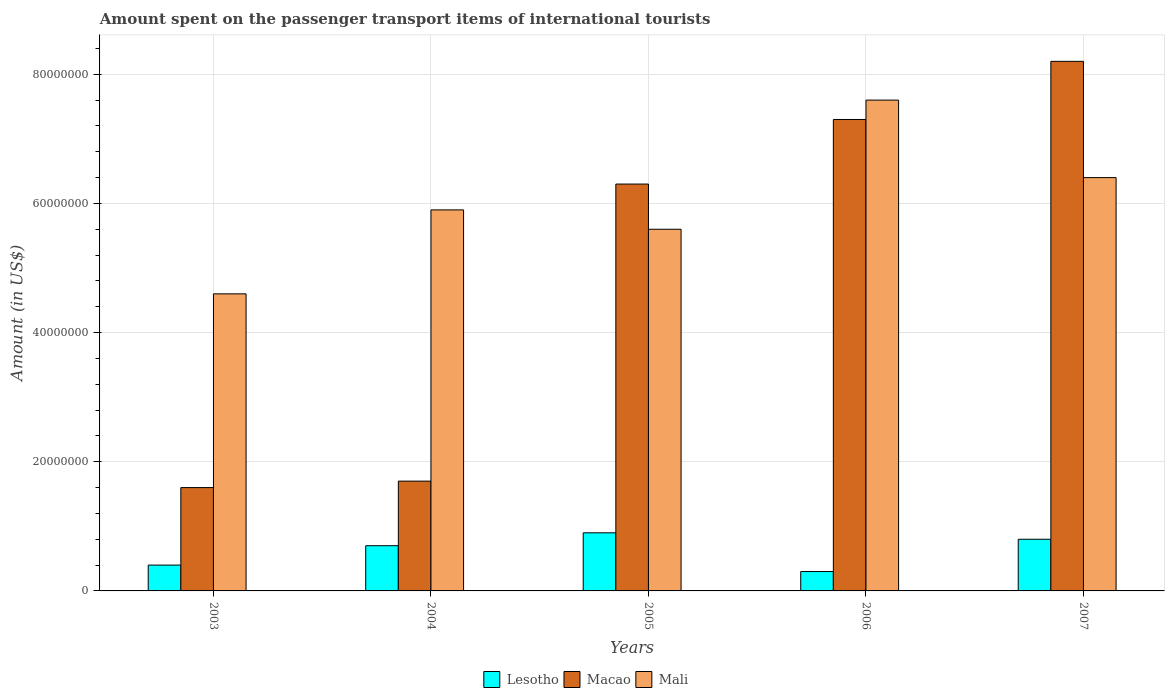Are the number of bars per tick equal to the number of legend labels?
Your answer should be compact. Yes. Are the number of bars on each tick of the X-axis equal?
Give a very brief answer. Yes. How many bars are there on the 4th tick from the left?
Make the answer very short. 3. What is the amount spent on the passenger transport items of international tourists in Mali in 2004?
Make the answer very short. 5.90e+07. Across all years, what is the maximum amount spent on the passenger transport items of international tourists in Mali?
Make the answer very short. 7.60e+07. Across all years, what is the minimum amount spent on the passenger transport items of international tourists in Macao?
Keep it short and to the point. 1.60e+07. In which year was the amount spent on the passenger transport items of international tourists in Mali maximum?
Offer a terse response. 2006. In which year was the amount spent on the passenger transport items of international tourists in Lesotho minimum?
Make the answer very short. 2006. What is the total amount spent on the passenger transport items of international tourists in Mali in the graph?
Provide a succinct answer. 3.01e+08. What is the difference between the amount spent on the passenger transport items of international tourists in Macao in 2005 and that in 2006?
Ensure brevity in your answer.  -1.00e+07. What is the difference between the amount spent on the passenger transport items of international tourists in Lesotho in 2007 and the amount spent on the passenger transport items of international tourists in Macao in 2003?
Your response must be concise. -8.00e+06. What is the average amount spent on the passenger transport items of international tourists in Lesotho per year?
Offer a terse response. 6.20e+06. In the year 2006, what is the difference between the amount spent on the passenger transport items of international tourists in Macao and amount spent on the passenger transport items of international tourists in Lesotho?
Provide a short and direct response. 7.00e+07. In how many years, is the amount spent on the passenger transport items of international tourists in Macao greater than 72000000 US$?
Offer a terse response. 2. What is the ratio of the amount spent on the passenger transport items of international tourists in Macao in 2003 to that in 2007?
Offer a terse response. 0.2. Is the difference between the amount spent on the passenger transport items of international tourists in Macao in 2005 and 2007 greater than the difference between the amount spent on the passenger transport items of international tourists in Lesotho in 2005 and 2007?
Ensure brevity in your answer.  No. What is the difference between the highest and the second highest amount spent on the passenger transport items of international tourists in Macao?
Keep it short and to the point. 9.00e+06. What is the difference between the highest and the lowest amount spent on the passenger transport items of international tourists in Macao?
Offer a very short reply. 6.60e+07. What does the 3rd bar from the left in 2003 represents?
Your answer should be very brief. Mali. What does the 2nd bar from the right in 2004 represents?
Offer a very short reply. Macao. Is it the case that in every year, the sum of the amount spent on the passenger transport items of international tourists in Lesotho and amount spent on the passenger transport items of international tourists in Mali is greater than the amount spent on the passenger transport items of international tourists in Macao?
Offer a very short reply. No. What is the difference between two consecutive major ticks on the Y-axis?
Your response must be concise. 2.00e+07. Are the values on the major ticks of Y-axis written in scientific E-notation?
Your answer should be compact. No. How many legend labels are there?
Offer a terse response. 3. What is the title of the graph?
Give a very brief answer. Amount spent on the passenger transport items of international tourists. What is the label or title of the X-axis?
Offer a terse response. Years. What is the label or title of the Y-axis?
Provide a short and direct response. Amount (in US$). What is the Amount (in US$) of Lesotho in 2003?
Your answer should be compact. 4.00e+06. What is the Amount (in US$) in Macao in 2003?
Offer a terse response. 1.60e+07. What is the Amount (in US$) of Mali in 2003?
Keep it short and to the point. 4.60e+07. What is the Amount (in US$) of Macao in 2004?
Offer a very short reply. 1.70e+07. What is the Amount (in US$) in Mali in 2004?
Offer a terse response. 5.90e+07. What is the Amount (in US$) in Lesotho in 2005?
Give a very brief answer. 9.00e+06. What is the Amount (in US$) of Macao in 2005?
Provide a short and direct response. 6.30e+07. What is the Amount (in US$) of Mali in 2005?
Your response must be concise. 5.60e+07. What is the Amount (in US$) of Macao in 2006?
Ensure brevity in your answer.  7.30e+07. What is the Amount (in US$) of Mali in 2006?
Your response must be concise. 7.60e+07. What is the Amount (in US$) in Macao in 2007?
Your answer should be compact. 8.20e+07. What is the Amount (in US$) in Mali in 2007?
Keep it short and to the point. 6.40e+07. Across all years, what is the maximum Amount (in US$) of Lesotho?
Provide a succinct answer. 9.00e+06. Across all years, what is the maximum Amount (in US$) of Macao?
Provide a short and direct response. 8.20e+07. Across all years, what is the maximum Amount (in US$) in Mali?
Offer a terse response. 7.60e+07. Across all years, what is the minimum Amount (in US$) in Macao?
Your response must be concise. 1.60e+07. Across all years, what is the minimum Amount (in US$) in Mali?
Your answer should be compact. 4.60e+07. What is the total Amount (in US$) of Lesotho in the graph?
Your response must be concise. 3.10e+07. What is the total Amount (in US$) of Macao in the graph?
Your response must be concise. 2.51e+08. What is the total Amount (in US$) in Mali in the graph?
Give a very brief answer. 3.01e+08. What is the difference between the Amount (in US$) in Lesotho in 2003 and that in 2004?
Offer a very short reply. -3.00e+06. What is the difference between the Amount (in US$) in Macao in 2003 and that in 2004?
Offer a terse response. -1.00e+06. What is the difference between the Amount (in US$) of Mali in 2003 and that in 2004?
Keep it short and to the point. -1.30e+07. What is the difference between the Amount (in US$) of Lesotho in 2003 and that in 2005?
Keep it short and to the point. -5.00e+06. What is the difference between the Amount (in US$) in Macao in 2003 and that in 2005?
Your answer should be very brief. -4.70e+07. What is the difference between the Amount (in US$) of Mali in 2003 and that in 2005?
Keep it short and to the point. -1.00e+07. What is the difference between the Amount (in US$) of Lesotho in 2003 and that in 2006?
Your answer should be very brief. 1.00e+06. What is the difference between the Amount (in US$) of Macao in 2003 and that in 2006?
Give a very brief answer. -5.70e+07. What is the difference between the Amount (in US$) in Mali in 2003 and that in 2006?
Ensure brevity in your answer.  -3.00e+07. What is the difference between the Amount (in US$) in Lesotho in 2003 and that in 2007?
Offer a terse response. -4.00e+06. What is the difference between the Amount (in US$) in Macao in 2003 and that in 2007?
Offer a terse response. -6.60e+07. What is the difference between the Amount (in US$) of Mali in 2003 and that in 2007?
Give a very brief answer. -1.80e+07. What is the difference between the Amount (in US$) in Macao in 2004 and that in 2005?
Give a very brief answer. -4.60e+07. What is the difference between the Amount (in US$) of Mali in 2004 and that in 2005?
Provide a short and direct response. 3.00e+06. What is the difference between the Amount (in US$) of Macao in 2004 and that in 2006?
Keep it short and to the point. -5.60e+07. What is the difference between the Amount (in US$) in Mali in 2004 and that in 2006?
Your response must be concise. -1.70e+07. What is the difference between the Amount (in US$) of Lesotho in 2004 and that in 2007?
Ensure brevity in your answer.  -1.00e+06. What is the difference between the Amount (in US$) in Macao in 2004 and that in 2007?
Your response must be concise. -6.50e+07. What is the difference between the Amount (in US$) in Mali in 2004 and that in 2007?
Ensure brevity in your answer.  -5.00e+06. What is the difference between the Amount (in US$) of Lesotho in 2005 and that in 2006?
Provide a short and direct response. 6.00e+06. What is the difference between the Amount (in US$) of Macao in 2005 and that in 2006?
Your answer should be very brief. -1.00e+07. What is the difference between the Amount (in US$) of Mali in 2005 and that in 2006?
Your response must be concise. -2.00e+07. What is the difference between the Amount (in US$) in Lesotho in 2005 and that in 2007?
Keep it short and to the point. 1.00e+06. What is the difference between the Amount (in US$) of Macao in 2005 and that in 2007?
Keep it short and to the point. -1.90e+07. What is the difference between the Amount (in US$) in Mali in 2005 and that in 2007?
Offer a very short reply. -8.00e+06. What is the difference between the Amount (in US$) of Lesotho in 2006 and that in 2007?
Your answer should be compact. -5.00e+06. What is the difference between the Amount (in US$) of Macao in 2006 and that in 2007?
Offer a terse response. -9.00e+06. What is the difference between the Amount (in US$) of Mali in 2006 and that in 2007?
Offer a terse response. 1.20e+07. What is the difference between the Amount (in US$) of Lesotho in 2003 and the Amount (in US$) of Macao in 2004?
Offer a very short reply. -1.30e+07. What is the difference between the Amount (in US$) in Lesotho in 2003 and the Amount (in US$) in Mali in 2004?
Give a very brief answer. -5.50e+07. What is the difference between the Amount (in US$) of Macao in 2003 and the Amount (in US$) of Mali in 2004?
Your answer should be compact. -4.30e+07. What is the difference between the Amount (in US$) in Lesotho in 2003 and the Amount (in US$) in Macao in 2005?
Provide a succinct answer. -5.90e+07. What is the difference between the Amount (in US$) in Lesotho in 2003 and the Amount (in US$) in Mali in 2005?
Your response must be concise. -5.20e+07. What is the difference between the Amount (in US$) of Macao in 2003 and the Amount (in US$) of Mali in 2005?
Offer a very short reply. -4.00e+07. What is the difference between the Amount (in US$) of Lesotho in 2003 and the Amount (in US$) of Macao in 2006?
Your response must be concise. -6.90e+07. What is the difference between the Amount (in US$) in Lesotho in 2003 and the Amount (in US$) in Mali in 2006?
Provide a short and direct response. -7.20e+07. What is the difference between the Amount (in US$) of Macao in 2003 and the Amount (in US$) of Mali in 2006?
Offer a terse response. -6.00e+07. What is the difference between the Amount (in US$) in Lesotho in 2003 and the Amount (in US$) in Macao in 2007?
Make the answer very short. -7.80e+07. What is the difference between the Amount (in US$) in Lesotho in 2003 and the Amount (in US$) in Mali in 2007?
Offer a terse response. -6.00e+07. What is the difference between the Amount (in US$) in Macao in 2003 and the Amount (in US$) in Mali in 2007?
Offer a very short reply. -4.80e+07. What is the difference between the Amount (in US$) of Lesotho in 2004 and the Amount (in US$) of Macao in 2005?
Your answer should be very brief. -5.60e+07. What is the difference between the Amount (in US$) in Lesotho in 2004 and the Amount (in US$) in Mali in 2005?
Ensure brevity in your answer.  -4.90e+07. What is the difference between the Amount (in US$) in Macao in 2004 and the Amount (in US$) in Mali in 2005?
Provide a succinct answer. -3.90e+07. What is the difference between the Amount (in US$) of Lesotho in 2004 and the Amount (in US$) of Macao in 2006?
Offer a terse response. -6.60e+07. What is the difference between the Amount (in US$) of Lesotho in 2004 and the Amount (in US$) of Mali in 2006?
Give a very brief answer. -6.90e+07. What is the difference between the Amount (in US$) of Macao in 2004 and the Amount (in US$) of Mali in 2006?
Your answer should be compact. -5.90e+07. What is the difference between the Amount (in US$) of Lesotho in 2004 and the Amount (in US$) of Macao in 2007?
Give a very brief answer. -7.50e+07. What is the difference between the Amount (in US$) in Lesotho in 2004 and the Amount (in US$) in Mali in 2007?
Keep it short and to the point. -5.70e+07. What is the difference between the Amount (in US$) in Macao in 2004 and the Amount (in US$) in Mali in 2007?
Your answer should be compact. -4.70e+07. What is the difference between the Amount (in US$) of Lesotho in 2005 and the Amount (in US$) of Macao in 2006?
Keep it short and to the point. -6.40e+07. What is the difference between the Amount (in US$) in Lesotho in 2005 and the Amount (in US$) in Mali in 2006?
Make the answer very short. -6.70e+07. What is the difference between the Amount (in US$) in Macao in 2005 and the Amount (in US$) in Mali in 2006?
Offer a very short reply. -1.30e+07. What is the difference between the Amount (in US$) in Lesotho in 2005 and the Amount (in US$) in Macao in 2007?
Provide a short and direct response. -7.30e+07. What is the difference between the Amount (in US$) of Lesotho in 2005 and the Amount (in US$) of Mali in 2007?
Give a very brief answer. -5.50e+07. What is the difference between the Amount (in US$) of Lesotho in 2006 and the Amount (in US$) of Macao in 2007?
Your response must be concise. -7.90e+07. What is the difference between the Amount (in US$) in Lesotho in 2006 and the Amount (in US$) in Mali in 2007?
Provide a short and direct response. -6.10e+07. What is the difference between the Amount (in US$) of Macao in 2006 and the Amount (in US$) of Mali in 2007?
Make the answer very short. 9.00e+06. What is the average Amount (in US$) of Lesotho per year?
Offer a very short reply. 6.20e+06. What is the average Amount (in US$) in Macao per year?
Give a very brief answer. 5.02e+07. What is the average Amount (in US$) in Mali per year?
Your response must be concise. 6.02e+07. In the year 2003, what is the difference between the Amount (in US$) of Lesotho and Amount (in US$) of Macao?
Your answer should be very brief. -1.20e+07. In the year 2003, what is the difference between the Amount (in US$) of Lesotho and Amount (in US$) of Mali?
Ensure brevity in your answer.  -4.20e+07. In the year 2003, what is the difference between the Amount (in US$) in Macao and Amount (in US$) in Mali?
Offer a very short reply. -3.00e+07. In the year 2004, what is the difference between the Amount (in US$) in Lesotho and Amount (in US$) in Macao?
Your answer should be compact. -1.00e+07. In the year 2004, what is the difference between the Amount (in US$) in Lesotho and Amount (in US$) in Mali?
Give a very brief answer. -5.20e+07. In the year 2004, what is the difference between the Amount (in US$) in Macao and Amount (in US$) in Mali?
Keep it short and to the point. -4.20e+07. In the year 2005, what is the difference between the Amount (in US$) in Lesotho and Amount (in US$) in Macao?
Provide a succinct answer. -5.40e+07. In the year 2005, what is the difference between the Amount (in US$) in Lesotho and Amount (in US$) in Mali?
Provide a succinct answer. -4.70e+07. In the year 2005, what is the difference between the Amount (in US$) of Macao and Amount (in US$) of Mali?
Your answer should be very brief. 7.00e+06. In the year 2006, what is the difference between the Amount (in US$) of Lesotho and Amount (in US$) of Macao?
Ensure brevity in your answer.  -7.00e+07. In the year 2006, what is the difference between the Amount (in US$) in Lesotho and Amount (in US$) in Mali?
Ensure brevity in your answer.  -7.30e+07. In the year 2007, what is the difference between the Amount (in US$) of Lesotho and Amount (in US$) of Macao?
Offer a terse response. -7.40e+07. In the year 2007, what is the difference between the Amount (in US$) of Lesotho and Amount (in US$) of Mali?
Ensure brevity in your answer.  -5.60e+07. In the year 2007, what is the difference between the Amount (in US$) in Macao and Amount (in US$) in Mali?
Offer a terse response. 1.80e+07. What is the ratio of the Amount (in US$) of Mali in 2003 to that in 2004?
Keep it short and to the point. 0.78. What is the ratio of the Amount (in US$) in Lesotho in 2003 to that in 2005?
Provide a succinct answer. 0.44. What is the ratio of the Amount (in US$) in Macao in 2003 to that in 2005?
Your answer should be very brief. 0.25. What is the ratio of the Amount (in US$) in Mali in 2003 to that in 2005?
Your response must be concise. 0.82. What is the ratio of the Amount (in US$) in Macao in 2003 to that in 2006?
Provide a short and direct response. 0.22. What is the ratio of the Amount (in US$) in Mali in 2003 to that in 2006?
Your response must be concise. 0.61. What is the ratio of the Amount (in US$) of Lesotho in 2003 to that in 2007?
Your answer should be very brief. 0.5. What is the ratio of the Amount (in US$) of Macao in 2003 to that in 2007?
Your answer should be very brief. 0.2. What is the ratio of the Amount (in US$) in Mali in 2003 to that in 2007?
Give a very brief answer. 0.72. What is the ratio of the Amount (in US$) of Lesotho in 2004 to that in 2005?
Your answer should be compact. 0.78. What is the ratio of the Amount (in US$) in Macao in 2004 to that in 2005?
Provide a succinct answer. 0.27. What is the ratio of the Amount (in US$) of Mali in 2004 to that in 2005?
Offer a very short reply. 1.05. What is the ratio of the Amount (in US$) in Lesotho in 2004 to that in 2006?
Provide a short and direct response. 2.33. What is the ratio of the Amount (in US$) of Macao in 2004 to that in 2006?
Keep it short and to the point. 0.23. What is the ratio of the Amount (in US$) of Mali in 2004 to that in 2006?
Your answer should be very brief. 0.78. What is the ratio of the Amount (in US$) of Macao in 2004 to that in 2007?
Your answer should be very brief. 0.21. What is the ratio of the Amount (in US$) in Mali in 2004 to that in 2007?
Give a very brief answer. 0.92. What is the ratio of the Amount (in US$) in Lesotho in 2005 to that in 2006?
Your response must be concise. 3. What is the ratio of the Amount (in US$) in Macao in 2005 to that in 2006?
Give a very brief answer. 0.86. What is the ratio of the Amount (in US$) in Mali in 2005 to that in 2006?
Provide a succinct answer. 0.74. What is the ratio of the Amount (in US$) in Lesotho in 2005 to that in 2007?
Give a very brief answer. 1.12. What is the ratio of the Amount (in US$) in Macao in 2005 to that in 2007?
Your answer should be compact. 0.77. What is the ratio of the Amount (in US$) in Macao in 2006 to that in 2007?
Your response must be concise. 0.89. What is the ratio of the Amount (in US$) in Mali in 2006 to that in 2007?
Offer a very short reply. 1.19. What is the difference between the highest and the second highest Amount (in US$) of Lesotho?
Your answer should be very brief. 1.00e+06. What is the difference between the highest and the second highest Amount (in US$) in Macao?
Your answer should be very brief. 9.00e+06. What is the difference between the highest and the lowest Amount (in US$) of Lesotho?
Your response must be concise. 6.00e+06. What is the difference between the highest and the lowest Amount (in US$) of Macao?
Offer a terse response. 6.60e+07. What is the difference between the highest and the lowest Amount (in US$) of Mali?
Keep it short and to the point. 3.00e+07. 